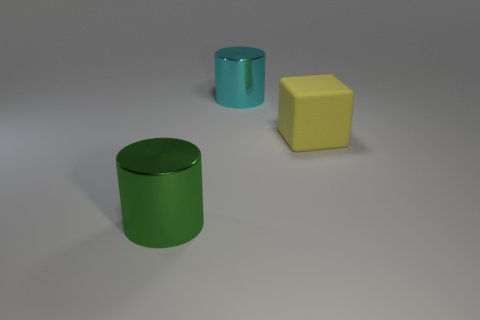What number of cyan cylinders have the same size as the yellow rubber block? 1 